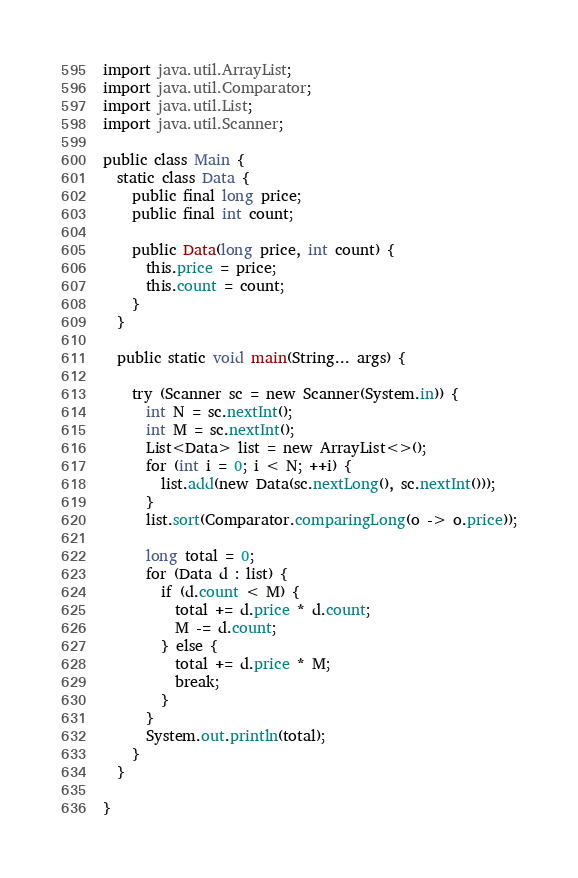Convert code to text. <code><loc_0><loc_0><loc_500><loc_500><_Java_>import java.util.ArrayList;
import java.util.Comparator;
import java.util.List;
import java.util.Scanner;

public class Main {
  static class Data {
    public final long price;
    public final int count;

    public Data(long price, int count) {
      this.price = price;
      this.count = count;
    }
  }

  public static void main(String... args) {

    try (Scanner sc = new Scanner(System.in)) {
      int N = sc.nextInt();
      int M = sc.nextInt();
      List<Data> list = new ArrayList<>();
      for (int i = 0; i < N; ++i) {
        list.add(new Data(sc.nextLong(), sc.nextInt()));
      }
      list.sort(Comparator.comparingLong(o -> o.price));

      long total = 0;
      for (Data d : list) {
        if (d.count < M) {
          total += d.price * d.count;
          M -= d.count;
        } else {
          total += d.price * M;
          break;
        }
      }
      System.out.println(total);
    }
  }

}</code> 